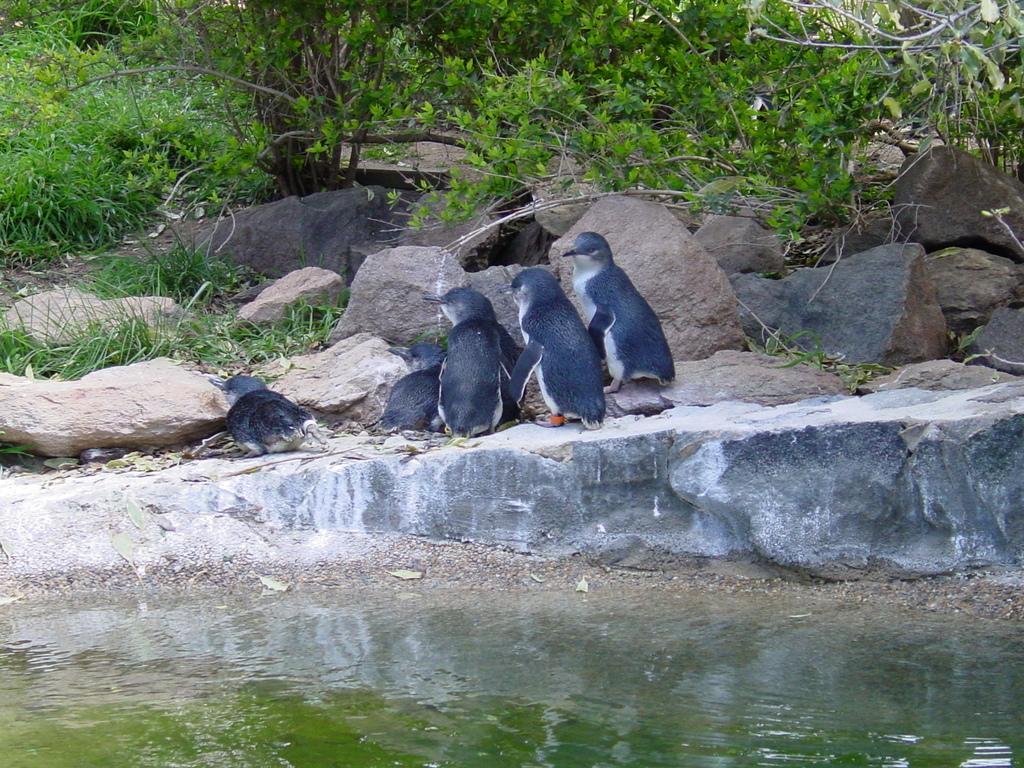Could you give a brief overview of what you see in this image? In this picture I can see water, there are penguins, rocks and there are trees. 